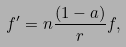Convert formula to latex. <formula><loc_0><loc_0><loc_500><loc_500>f ^ { \prime } = n \frac { ( 1 - a ) } { r } f ,</formula> 